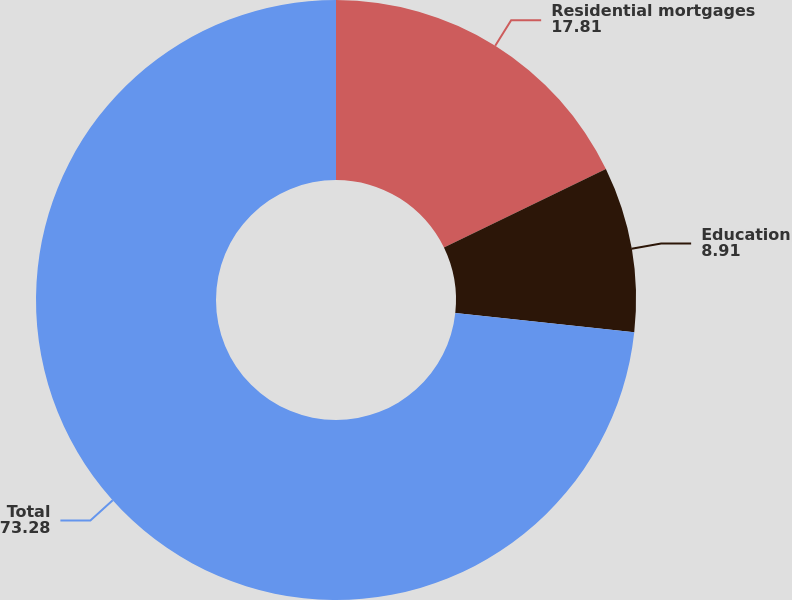<chart> <loc_0><loc_0><loc_500><loc_500><pie_chart><fcel>Residential mortgages<fcel>Education<fcel>Total<nl><fcel>17.81%<fcel>8.91%<fcel>73.28%<nl></chart> 